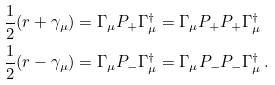Convert formula to latex. <formula><loc_0><loc_0><loc_500><loc_500>\frac { 1 } { 2 } ( r + \gamma _ { \mu } ) & = \Gamma _ { \mu } P _ { + } \Gamma _ { \mu } ^ { \dag } = \Gamma _ { \mu } P _ { + } P _ { + } \Gamma _ { \mu } ^ { \dag } \\ \frac { 1 } { 2 } ( r - \gamma _ { \mu } ) & = \Gamma _ { \mu } P _ { - } \Gamma _ { \mu } ^ { \dag } = \Gamma _ { \mu } P _ { - } P _ { - } \Gamma _ { \mu } ^ { \dag } \, .</formula> 